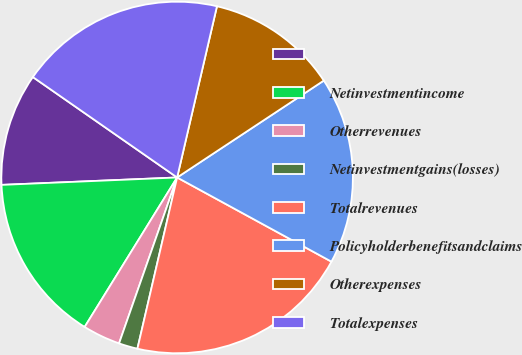Convert chart to OTSL. <chart><loc_0><loc_0><loc_500><loc_500><pie_chart><ecel><fcel>Netinvestmentincome<fcel>Otherrevenues<fcel>Netinvestmentgains(losses)<fcel>Totalrevenues<fcel>Policyholderbenefitsandclaims<fcel>Otherexpenses<fcel>Totalexpenses<nl><fcel>10.35%<fcel>15.51%<fcel>3.46%<fcel>1.73%<fcel>20.68%<fcel>17.24%<fcel>12.07%<fcel>18.96%<nl></chart> 